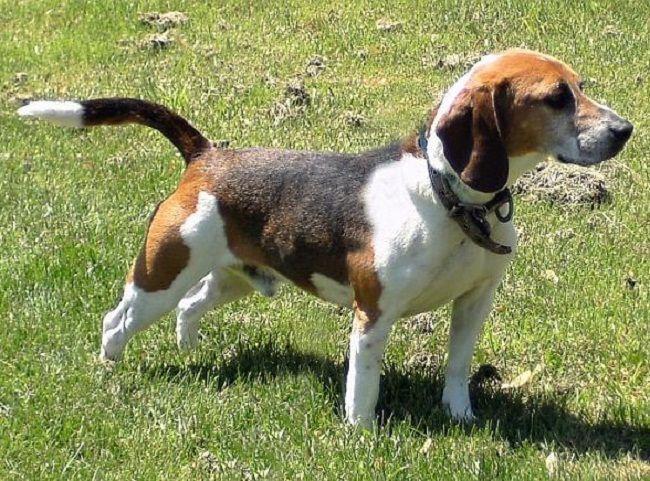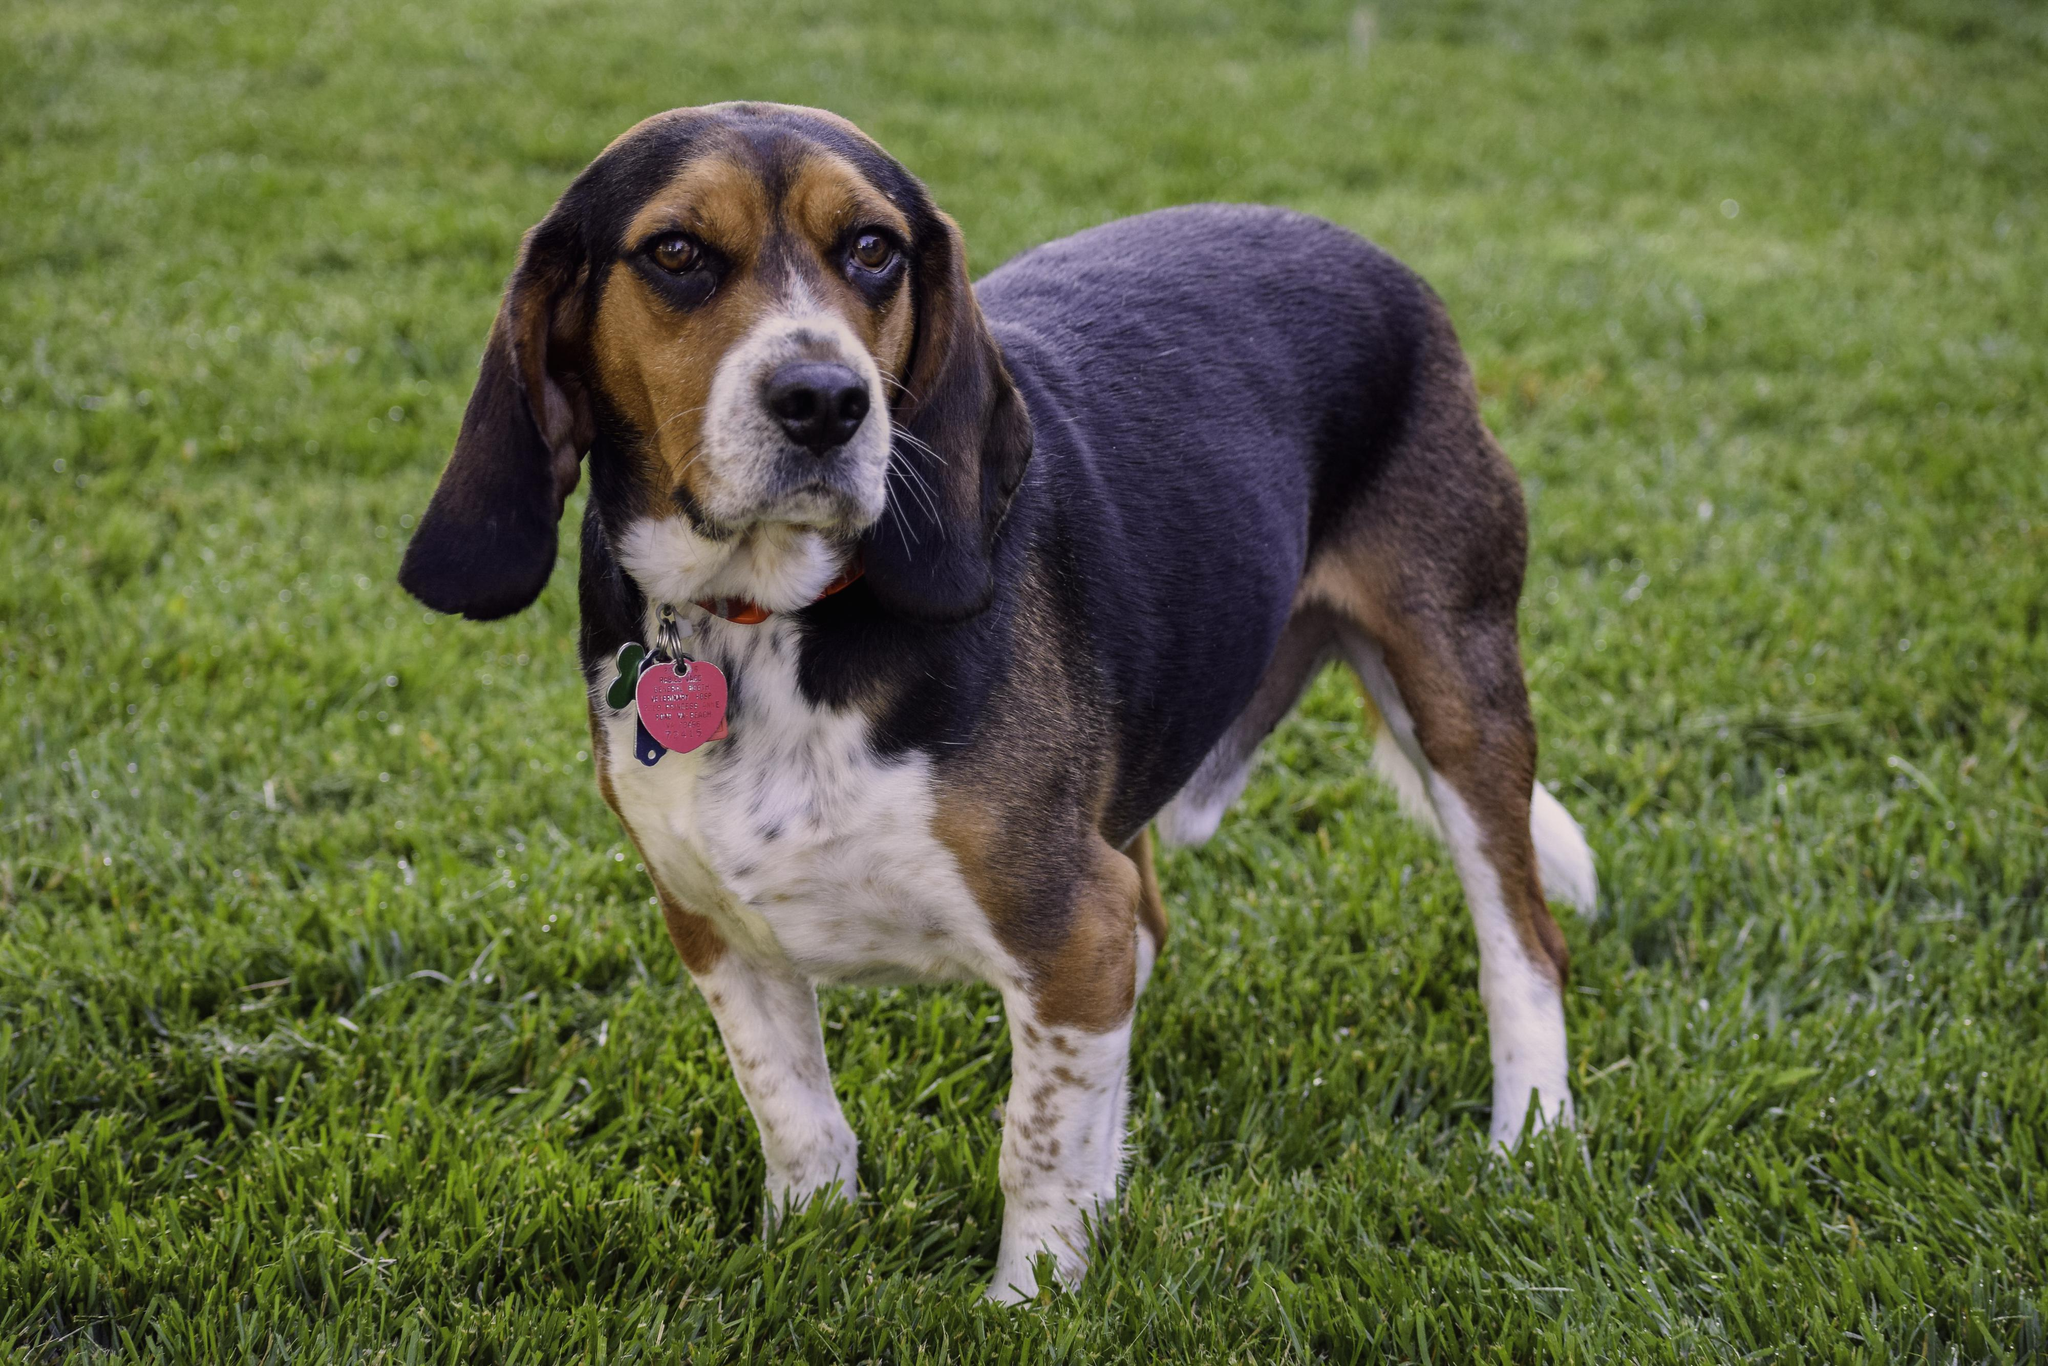The first image is the image on the left, the second image is the image on the right. Evaluate the accuracy of this statement regarding the images: "In the right image the dog is facing right, and in the left image the dog is facing left.". Is it true? Answer yes or no. No. 